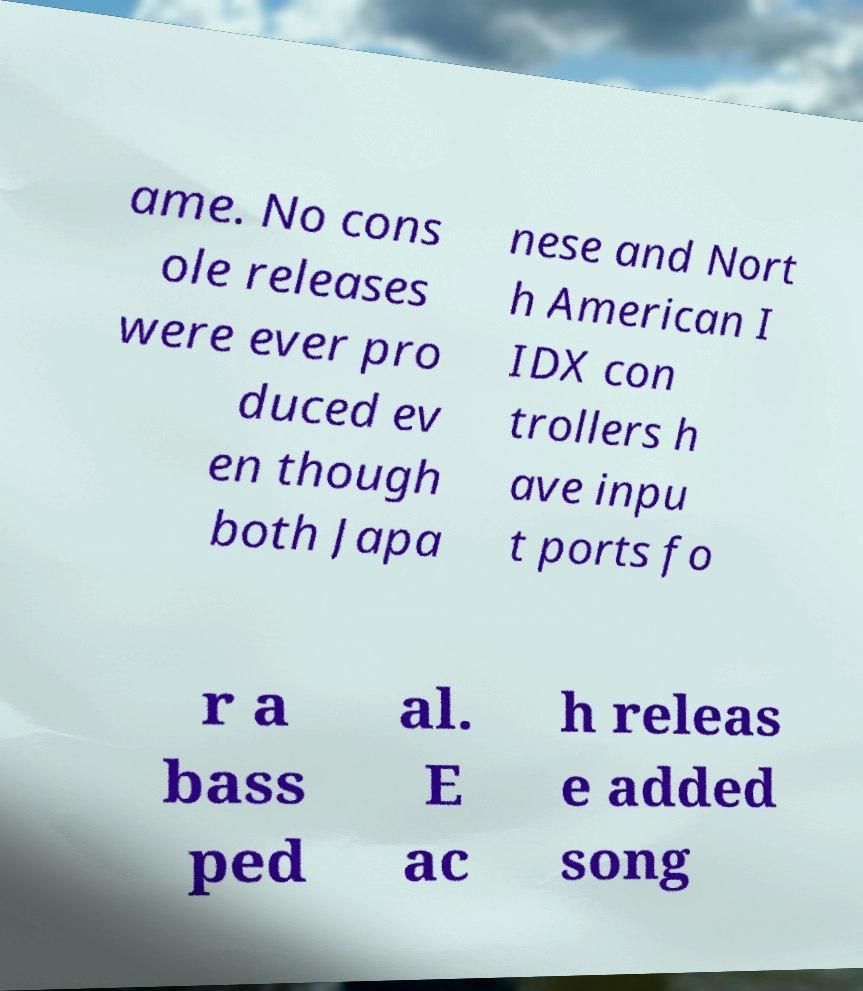Can you read and provide the text displayed in the image?This photo seems to have some interesting text. Can you extract and type it out for me? ame. No cons ole releases were ever pro duced ev en though both Japa nese and Nort h American I IDX con trollers h ave inpu t ports fo r a bass ped al. E ac h releas e added song 